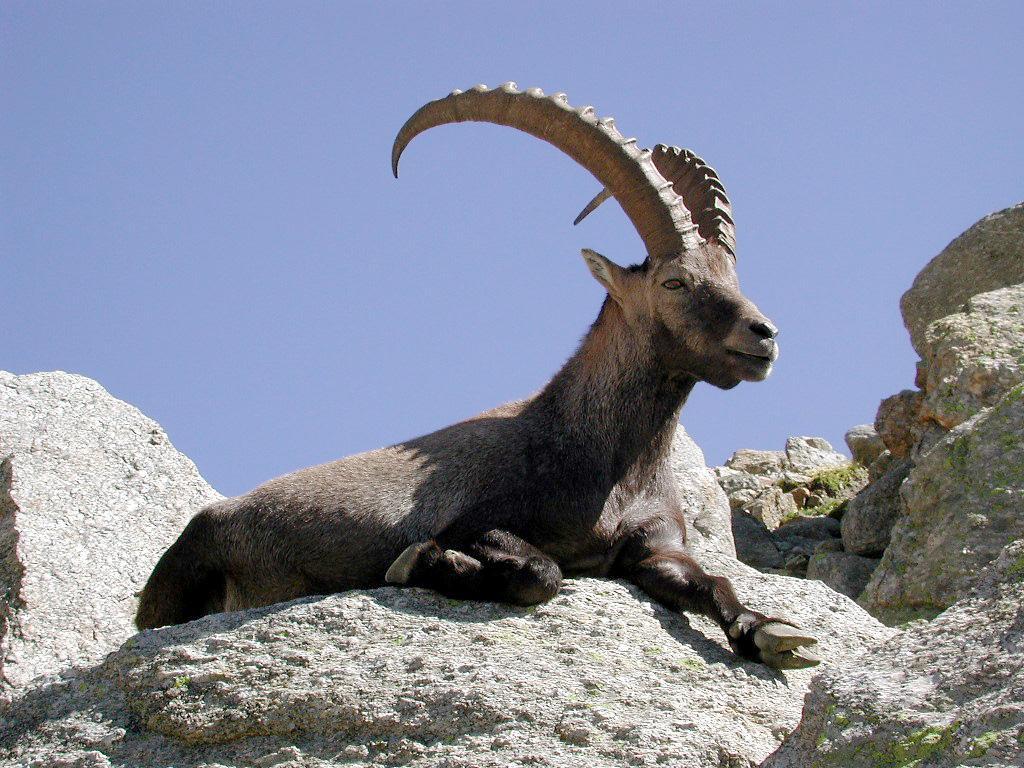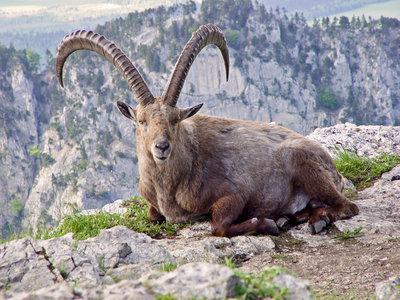The first image is the image on the left, the second image is the image on the right. Considering the images on both sides, is "There are at least two animals in the image on the left." valid? Answer yes or no. No. 